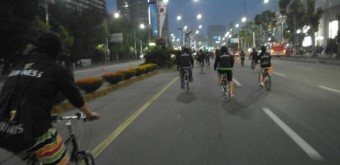How many bicycles are there in the image? 3 